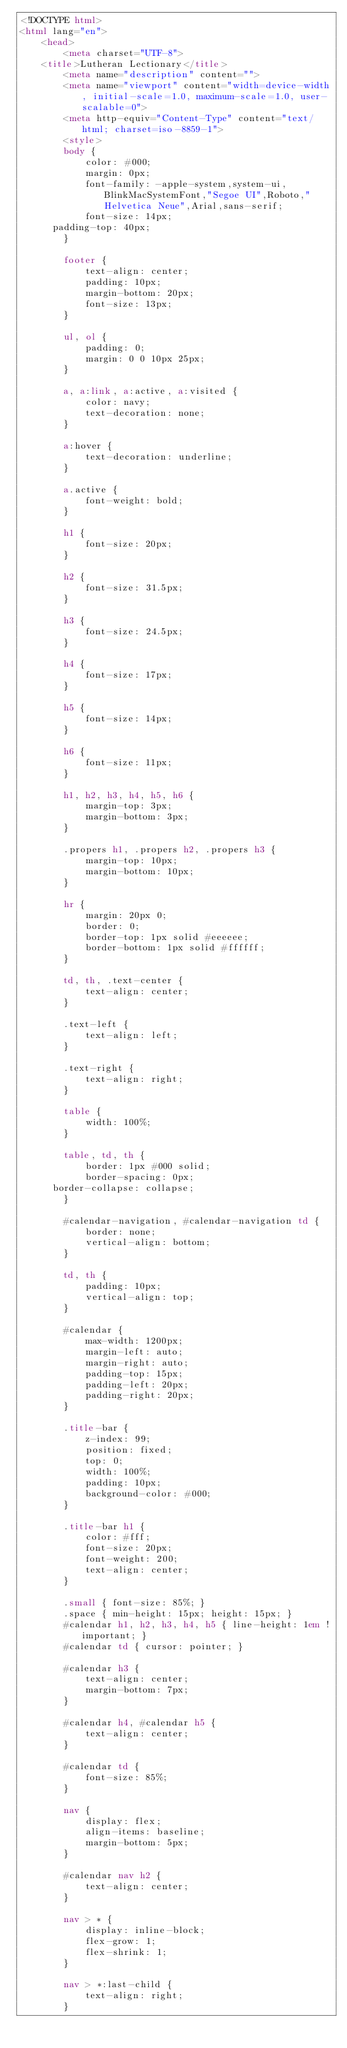Convert code to text. <code><loc_0><loc_0><loc_500><loc_500><_HTML_><!DOCTYPE html>
<html lang="en">
	<head>
		<meta charset="UTF-8">
    <title>Lutheran Lectionary</title>
		<meta name="description" content="">
		<meta name="viewport" content="width=device-width, initial-scale=1.0, maximum-scale=1.0, user-scalable=0">
		<meta http-equiv="Content-Type" content="text/html; charset=iso-8859-1">
		<style>
		body {
			color: #000;
			margin: 0px;
			font-family: -apple-system,system-ui,BlinkMacSystemFont,"Segoe UI",Roboto,"Helvetica Neue",Arial,sans-serif;
			font-size: 14px;
      padding-top: 40px;
		}

		footer {
			text-align: center;
			padding: 10px;
			margin-bottom: 20px;
			font-size: 13px;
		}

		ul, ol {
			padding: 0;
			margin: 0 0 10px 25px;
		}

		a, a:link, a:active, a:visited {
			color: navy;
			text-decoration: none;
		}

		a:hover {
			text-decoration: underline;
		}

		a.active {
			font-weight: bold;
		}

		h1 {
			font-size: 20px;
		}

		h2 {
			font-size: 31.5px;
		}

		h3 {
			font-size: 24.5px;
		}

		h4 {
			font-size: 17px;
		}

		h5 {
			font-size: 14px;
		}

		h6 {
			font-size: 11px;
		}

		h1, h2, h3, h4, h5, h6 {
			margin-top: 3px;
			margin-bottom: 3px;
		}

		.propers h1, .propers h2, .propers h3 {
			margin-top: 10px;
			margin-bottom: 10px;
		}

		hr {
			margin: 20px 0;
			border: 0;
			border-top: 1px solid #eeeeee;
			border-bottom: 1px solid #ffffff;
		}

		td, th, .text-center {
			text-align: center;
		}

		.text-left {
			text-align: left;
		}

		.text-right {
			text-align: right;
		}

		table {
			width: 100%;
		}

		table, td, th {
			border: 1px #000 solid;
			border-spacing: 0px;
      border-collapse: collapse;
		}

		#calendar-navigation, #calendar-navigation td {
			border: none;
			vertical-align: bottom;
		}

		td, th {
			padding: 10px;
			vertical-align: top;
		}

		#calendar {
			max-width: 1200px;
			margin-left: auto;
			margin-right: auto;
			padding-top: 15px;
			padding-left: 20px;
			padding-right: 20px;
		}

		.title-bar {
			z-index: 99;
			position: fixed;
			top: 0;
			width: 100%;
			padding: 10px;
			background-color: #000;
		}

		.title-bar h1 {
			color: #fff;
			font-size: 20px;
			font-weight: 200;
			text-align: center;
		}

		.small { font-size: 85%; }
		.space { min-height: 15px; height: 15px; }
		#calendar h1, h2, h3, h4, h5 { line-height: 1em !important; }
		#calendar td { cursor: pointer; }

		#calendar h3 {
			text-align: center;
			margin-bottom: 7px;
		}

		#calendar h4, #calendar h5 {
			text-align: center;
		}

		#calendar td {
			font-size: 85%;
		}

		nav {
			display: flex;
			align-items: baseline;
			margin-bottom: 5px;
		}

		#calendar nav h2 {
			text-align: center;
		}

		nav > * {
			display: inline-block;
			flex-grow: 1;
			flex-shrink: 1;
		}

		nav > *:last-child {
			text-align: right;
		}
</code> 